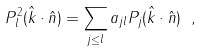<formula> <loc_0><loc_0><loc_500><loc_500>P _ { l } ^ { 2 } ( \hat { k } \cdot \hat { n } ) = \sum _ { j \leq l } a _ { j l } P _ { j } ( \hat { k } \cdot \hat { n } ) \ ,</formula> 